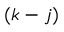Convert formula to latex. <formula><loc_0><loc_0><loc_500><loc_500>( k - j )</formula> 